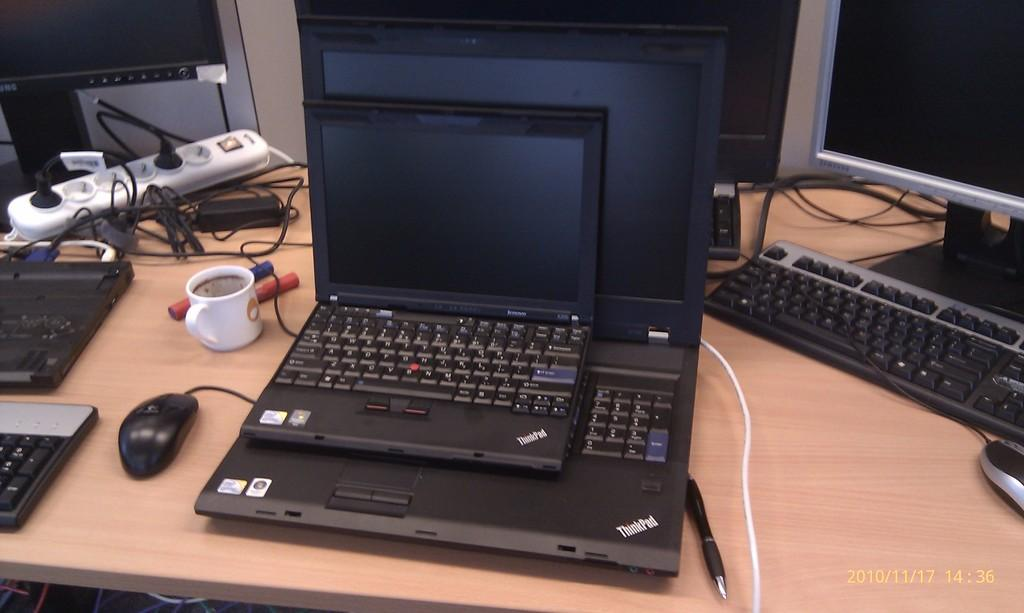Provide a one-sentence caption for the provided image. A small ThinkPad laptop is sitting on top of a larger ThinkPad laptop. 